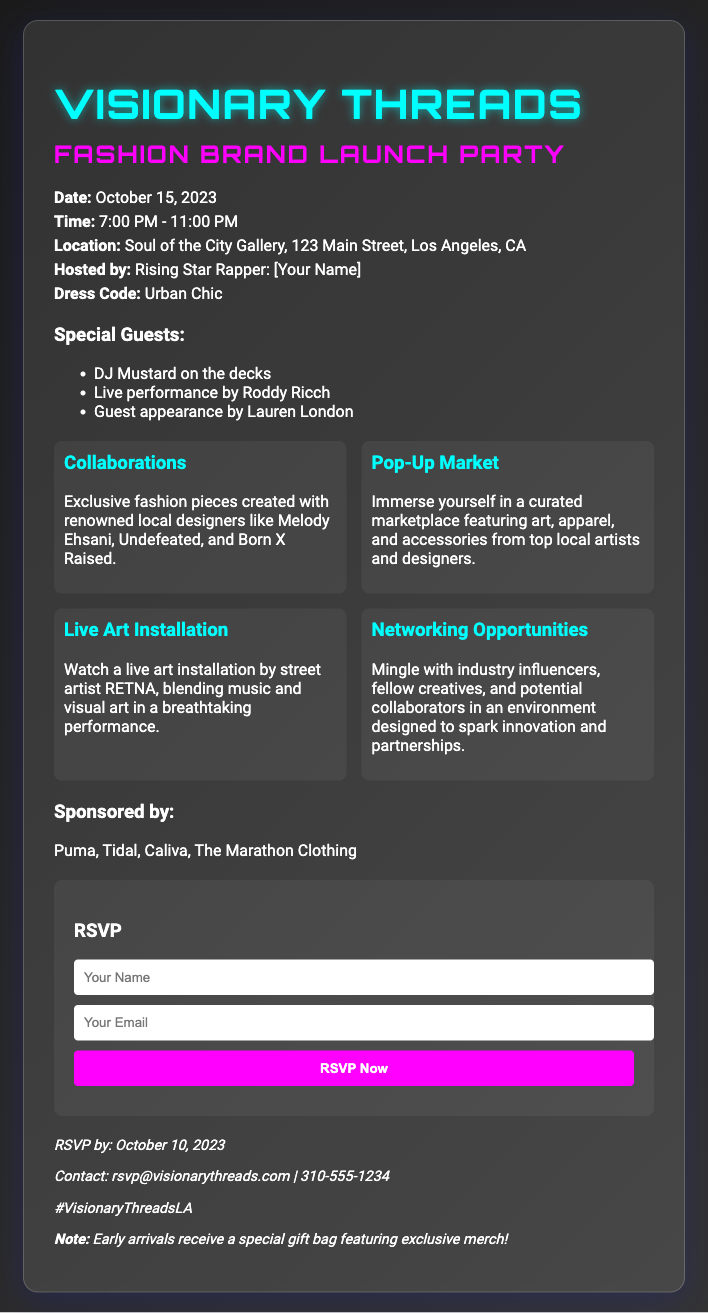what is the date of the event? The date of the event is provided in the event details section of the document.
Answer: October 15, 2023 what time does the event start? The starting time is listed in the event details under the time section.
Answer: 7:00 PM where is the location of the party? The location can be found in the event details, specifying the venue and address.
Answer: Soul of the City Gallery, 123 Main Street, Los Angeles, CA who are the special guests? The special guests are mentioned in a list format in their respective section.
Answer: DJ Mustard, Roddy Ricch, Lauren London what is the dress code for the event? The dress code is outlined clearly in the event details section.
Answer: Urban Chic what type of merchandise will be featured? The merchandise details are described under the collaborations highlight.
Answer: Exclusive fashion pieces how many highlights are listed? The number of highlights can be counted from the grid layout provided in the document.
Answer: Four when is the RSVP deadline? The RSVP deadline is stated in the extras section of the document.
Answer: October 10, 2023 what special offer is available for early arrivals? The document mentions a specific incentive for early arrivals in the extras section.
Answer: Special gift bag featuring exclusive merch 